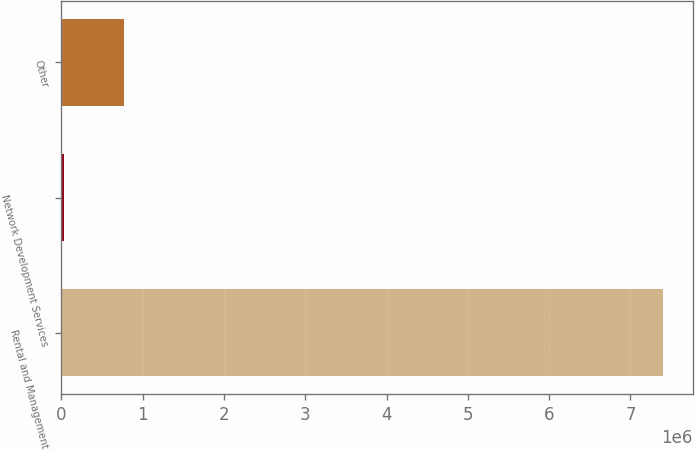Convert chart. <chart><loc_0><loc_0><loc_500><loc_500><bar_chart><fcel>Rental and Management<fcel>Network Development Services<fcel>Other<nl><fcel>7.39858e+06<fcel>30263<fcel>767095<nl></chart> 